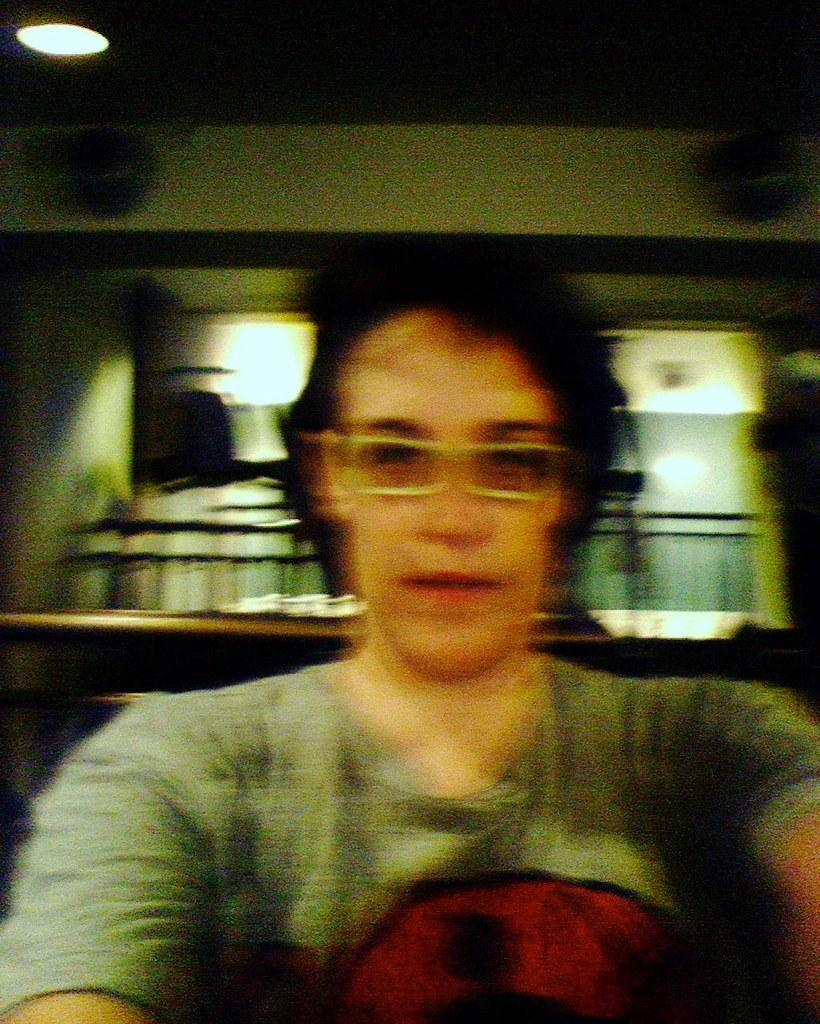Who is the main subject in the image? There is a person in the front of the image. What can be seen on the person's face? The person is wearing spectacles. Where is the light source located in the image? There is a light at the left top of the image. How would you describe the background of the image? The background of the image is blurry. What news is the person reading in the image? There is no news visible in the image; the person is not holding or reading anything. What order is the person following in the image? There is no indication of an order or sequence of actions in the image. 